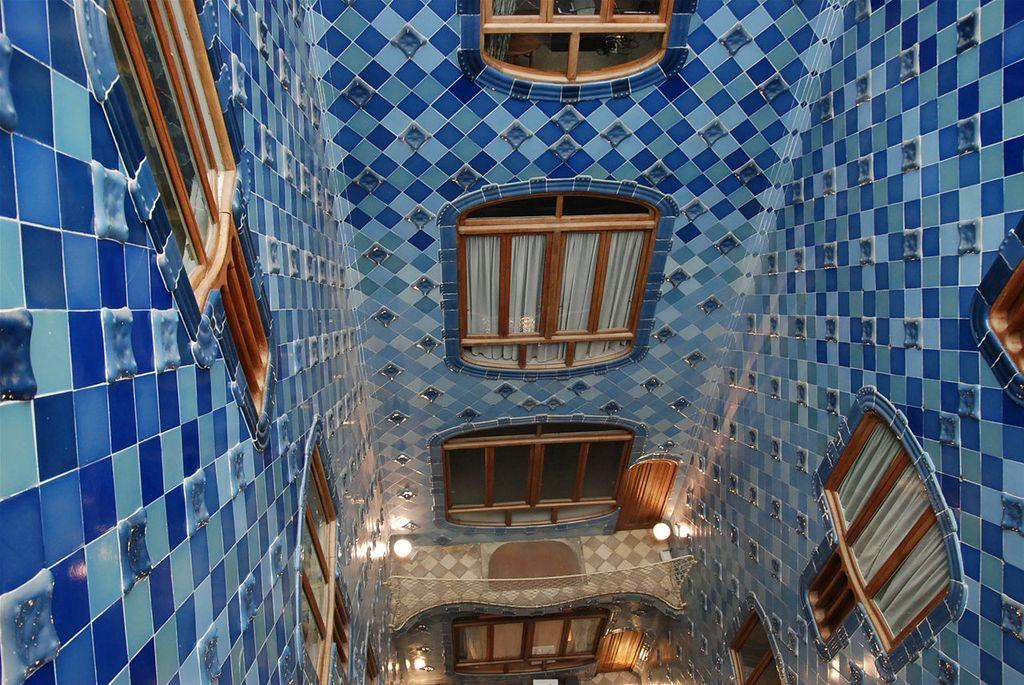What type of location is depicted in the image? The image is an inside picture of a room. What feature can be seen on the walls of the room? There are windows on the walls of the room. What is installed at the top of the roof in the room? There are lights at the top of the roof in the room. What type of vase can be seen on the hill in the image? There is no vase or hill present in the image; it is an inside picture of a room with windows and lights. 